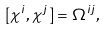<formula> <loc_0><loc_0><loc_500><loc_500>[ \chi ^ { i } , \chi ^ { j } ] = \Omega ^ { i j } ,</formula> 